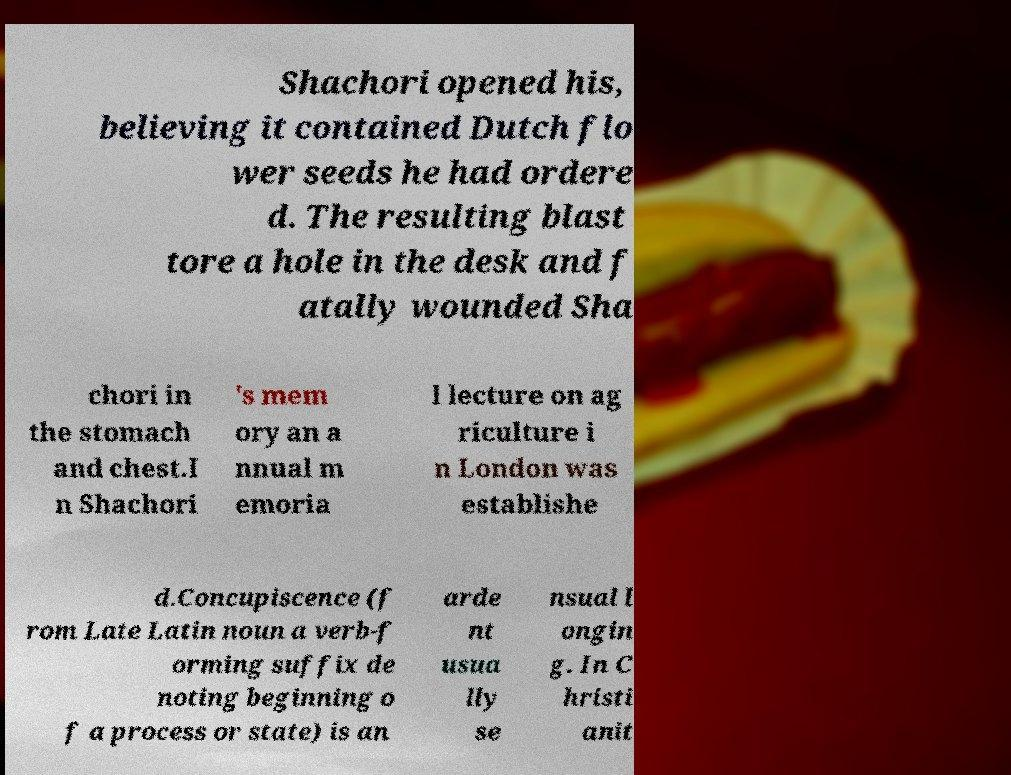Can you read and provide the text displayed in the image?This photo seems to have some interesting text. Can you extract and type it out for me? Shachori opened his, believing it contained Dutch flo wer seeds he had ordere d. The resulting blast tore a hole in the desk and f atally wounded Sha chori in the stomach and chest.I n Shachori 's mem ory an a nnual m emoria l lecture on ag riculture i n London was establishe d.Concupiscence (f rom Late Latin noun a verb-f orming suffix de noting beginning o f a process or state) is an arde nt usua lly se nsual l ongin g. In C hristi anit 